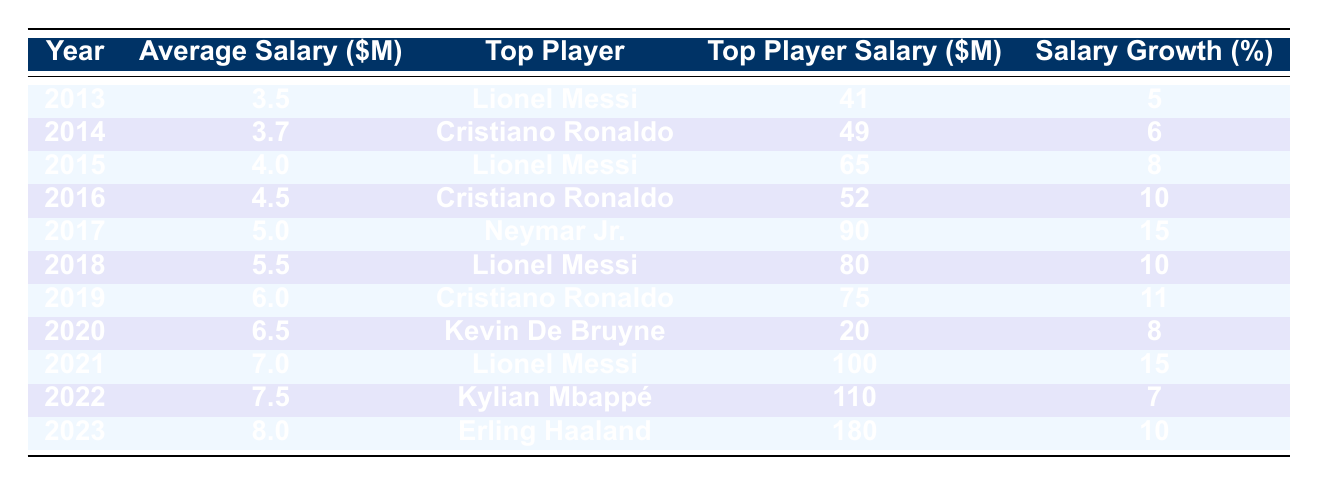What was the average salary of football players in 2019? From the table, the average salary for the year 2019 is listed directly under the corresponding column, which is 6.0 million dollars.
Answer: 6.0 Who was the top player in 2017 and what was his salary? The top player for the year 2017 is Neymar Jr. and his salary is reported as 90 million dollars in the table.
Answer: Neymar Jr., 90 million dollars What is the salary growth percentage from 2018 to 2019? To calculate the salary growth percentage from 2018 to 2019, take the salary in 2019 (6.0 million) and subtract the salary in 2018 (5.5 million), which gives 0.5 million. Then, divide by the 2018 salary (5.5 million) and multiply by 100 to get the percentage: (0.5 / 5.5) * 100 = approximately 9.09%.
Answer: Approximately 9.09% Did the average salary increase every year from 2013 to 2023? By examining the average salary in each year from the table, we see that the average salary has consistently increased year over year from 3.5 million in 2013 to 8.0 million in 2023, confirming this is true.
Answer: Yes What is the difference in salary growth percentage between 2016 and 2021? The salary growth percentage for 2016 is 10% and for 2021 is 15%. To find the difference, subtract 10% from 15%, which results in a difference of 5%.
Answer: 5% Who had the highest salary in 2023, and by how much does it exceed the average salary? In 2023, Erling Haaland had the highest salary at 180 million dollars. The average salary that year is 8.0 million dollars. The difference is calculated by subtracting the average salary from Haaland's salary: 180 - 8 = 172 million dollars.
Answer: 172 million dollars Which year had the lowest top player salary, and what was it? Reviewing the table, the lowest top player salary is found in 2020, where Kevin De Bruyne's salary is listed at 20 million dollars.
Answer: 2020, 20 million dollars What is the average salary across all years from 2013 to 2023? To find the average salary, sum the average salaries for each year: (3.5 + 3.7 + 4.0 + 4.5 + 5.0 + 5.5 + 6.0 + 6.5 + 7.0 + 7.5 + 8.0) = 54.2 million dollars. There are 11 years, so divide 54.2 by 11, resulting in approximately 4.93 million dollars.
Answer: Approximately 4.93 million dollars Which player saw the highest salary growth in a single year and what was the percentage? From the table, Neymar Jr. in 2017 experienced the highest salary growth percentage at 15%, which is the highest recorded in the entire dataset.
Answer: Neymar Jr., 15% In which year did Lionel Messi receive the highest salary, and what was that salary? From the table, it is clear that Lionel Messi received his highest salary in 2021, which was recorded at 100 million dollars.
Answer: 2021, 100 million dollars 